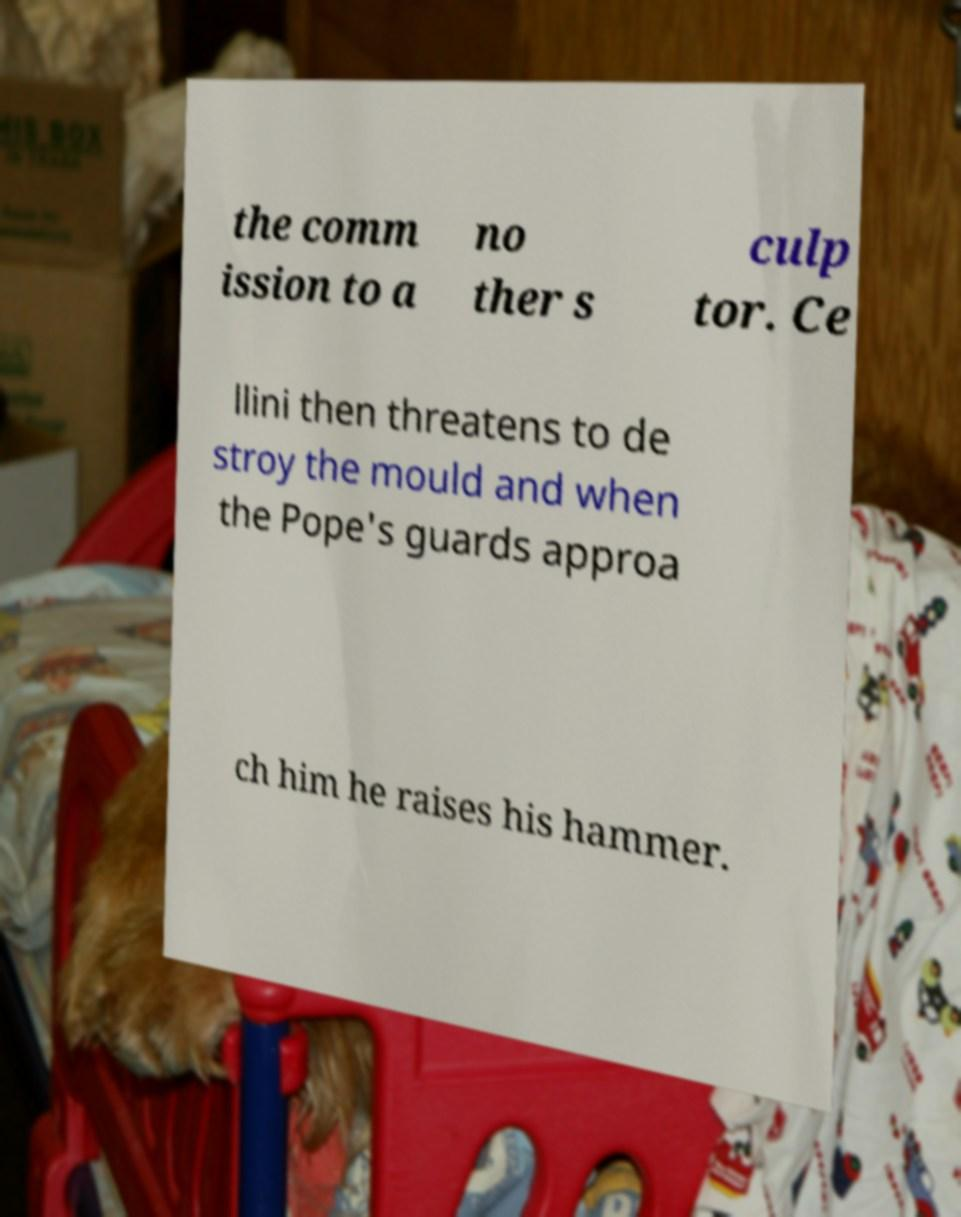Could you assist in decoding the text presented in this image and type it out clearly? the comm ission to a no ther s culp tor. Ce llini then threatens to de stroy the mould and when the Pope's guards approa ch him he raises his hammer. 